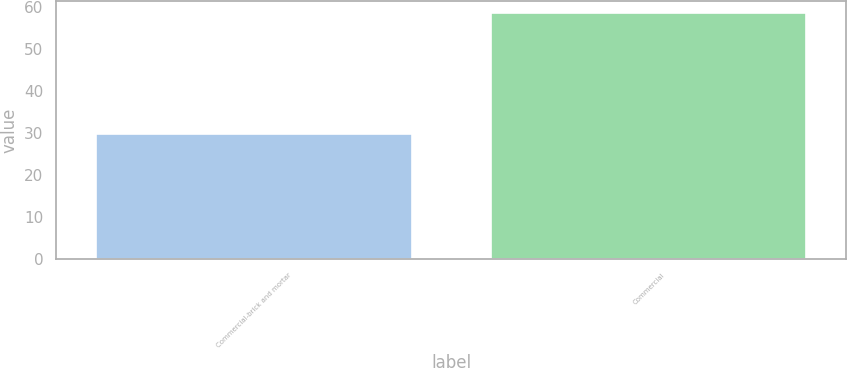<chart> <loc_0><loc_0><loc_500><loc_500><bar_chart><fcel>Commercial-brick and mortar<fcel>Commercial<nl><fcel>29.7<fcel>58.6<nl></chart> 